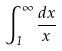<formula> <loc_0><loc_0><loc_500><loc_500>\int _ { 1 } ^ { \infty } \frac { d x } { x }</formula> 